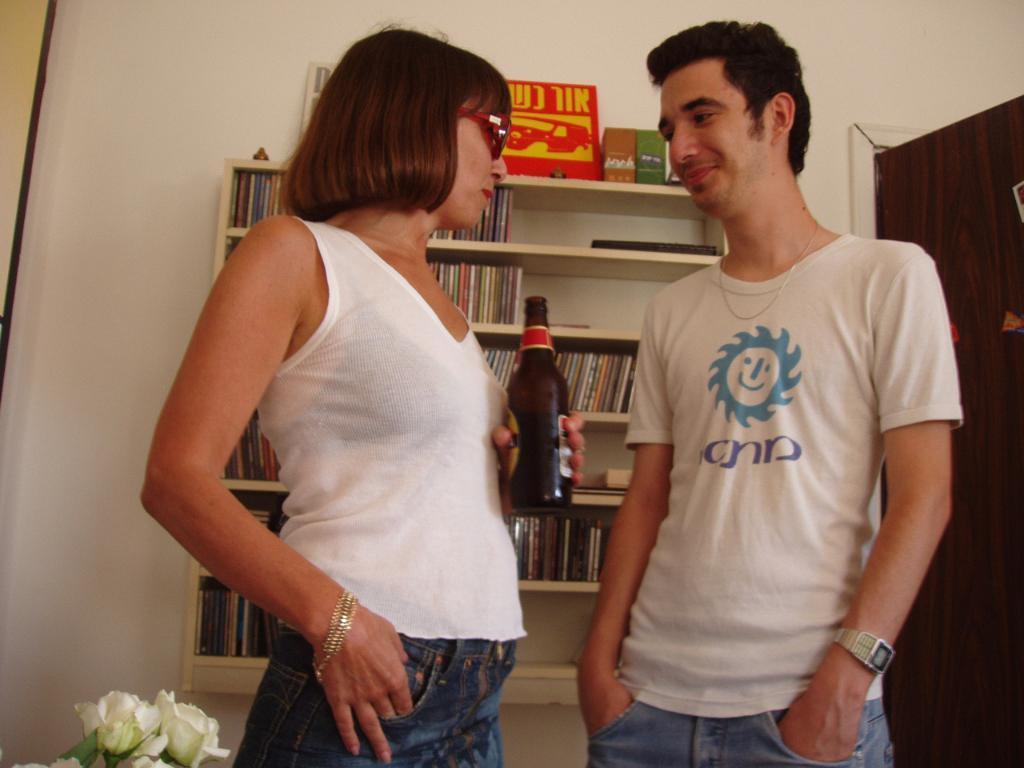Describe this image in one or two sentences. In this picture there are two person seeing each other. Left woman holding a bottle and right person is smiling. On the background there is a bookshelves. On the right side there is a door. And bottom left there is a flowers. 